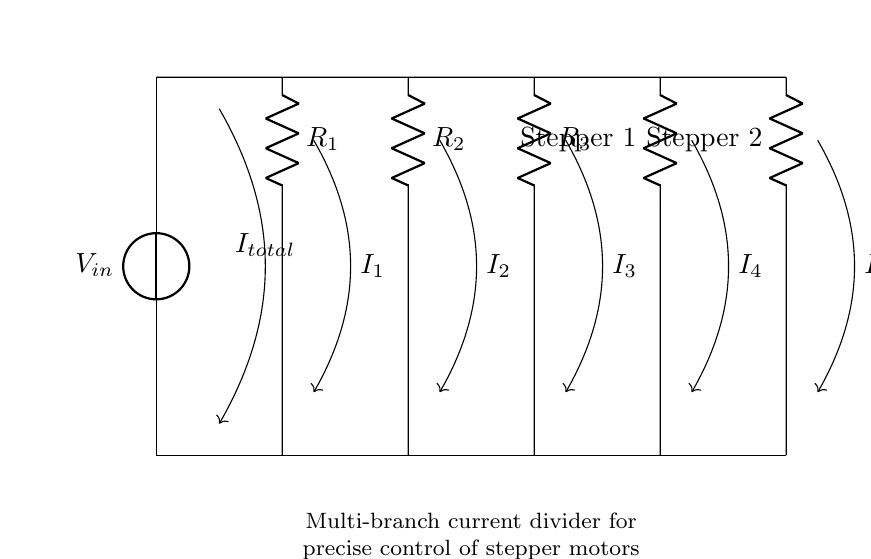What is the input voltage of the circuit? The input voltage, denoted by \( V_{in} \), is indicated by the voltage source symbol in the circuit diagram. It represents the initial voltage applied across the circuit.
Answer: \( V_{in} \) How many resistors are in this circuit? The circuit diagram shows a total of five resistors labeled from \( R_1 \) to \( R_5 \), arranged in parallel as part of the current divider configuration.
Answer: 5 What do \( R_4 \) and \( R_5 \) represent? \( R_4 \) and \( R_5 \) are labeled as the load resistors for Stepper 1 and Stepper 2, respectively, indicating that these resistors provide current to the stepper motors in the 3D printer's extruder system.
Answer: Stepper motors What is the total current flowing into the circuit? The total current \( I_{total} \) enters the circuit from the voltage source and is indicated by the arrow leading into the circuit, showing it is split among the branches.
Answer: \( I_{total} \) Which resistor has the lowest resistance value? In the context of this current divider, the resistor with the lowest resistance value would take a larger share of the total current. Since specific resistance values are not shown, we can't determine which one it is without numerical data. However, it would be the one directly affecting the higher current flow.
Answer: Undetermined 